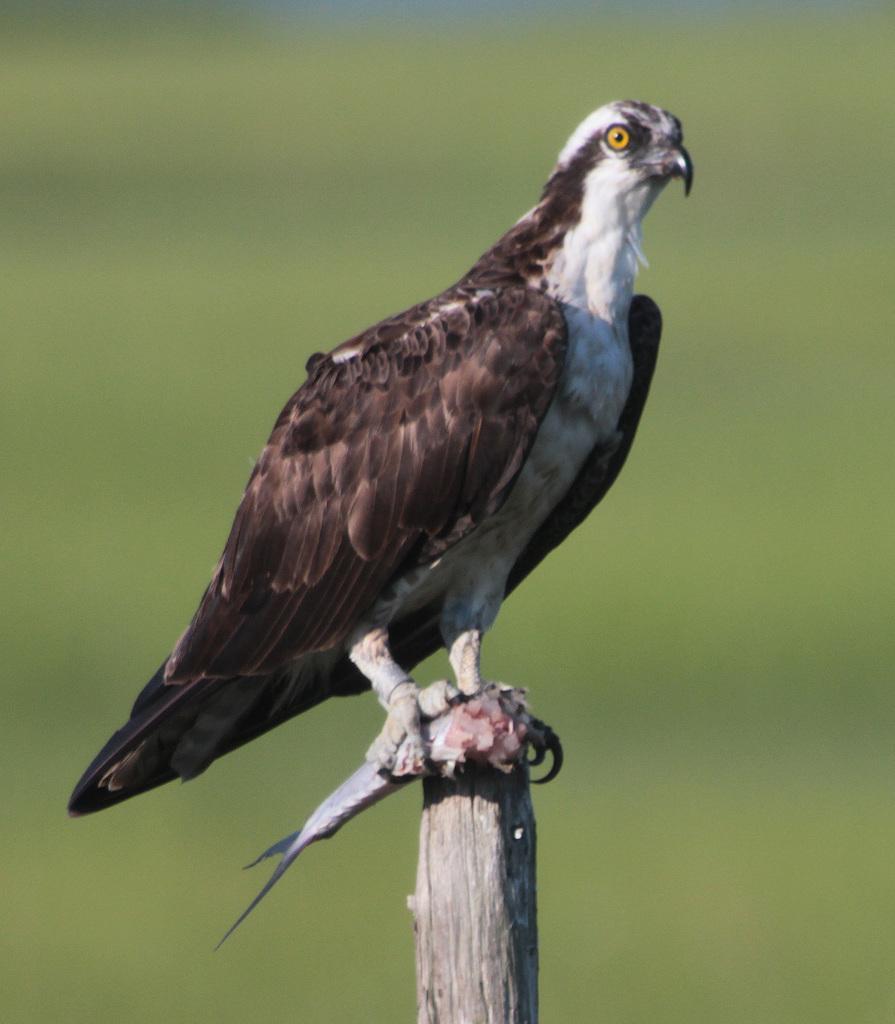In one or two sentences, can you explain what this image depicts? In this picture there is a bird on the pole and holding the fish. At the back the image is blurry. 